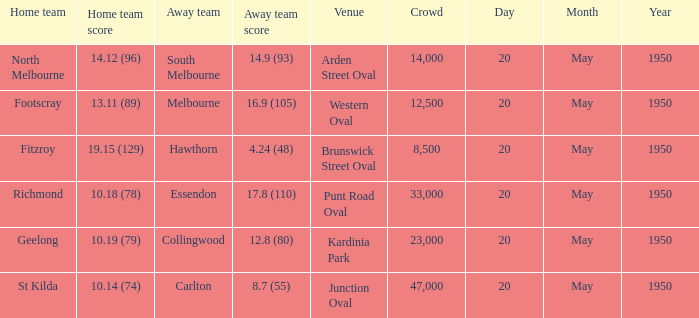When fitzroy was the home team, what was the score for the opposing team? 4.24 (48). 